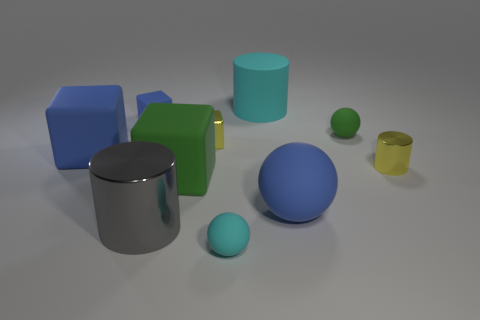Is there a tiny sphere that has the same color as the matte cylinder?
Ensure brevity in your answer.  Yes. Does the metallic thing that is behind the yellow cylinder have the same size as the gray thing?
Make the answer very short. No. Are there fewer big blue rubber blocks than purple cylinders?
Your answer should be very brief. No. Is there a large green cylinder that has the same material as the big blue block?
Offer a very short reply. No. The blue matte object that is to the right of the tiny blue thing has what shape?
Keep it short and to the point. Sphere. Is the color of the big cube that is in front of the tiny metallic cylinder the same as the large shiny thing?
Offer a very short reply. No. Are there fewer matte spheres that are on the left side of the blue sphere than tiny cyan matte things?
Make the answer very short. No. The small block that is made of the same material as the big cyan thing is what color?
Give a very brief answer. Blue. There is a metal cylinder behind the big matte sphere; what size is it?
Give a very brief answer. Small. Does the big gray object have the same material as the small cyan ball?
Provide a succinct answer. No. 